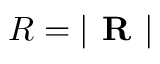<formula> <loc_0><loc_0><loc_500><loc_500>R = | R |</formula> 